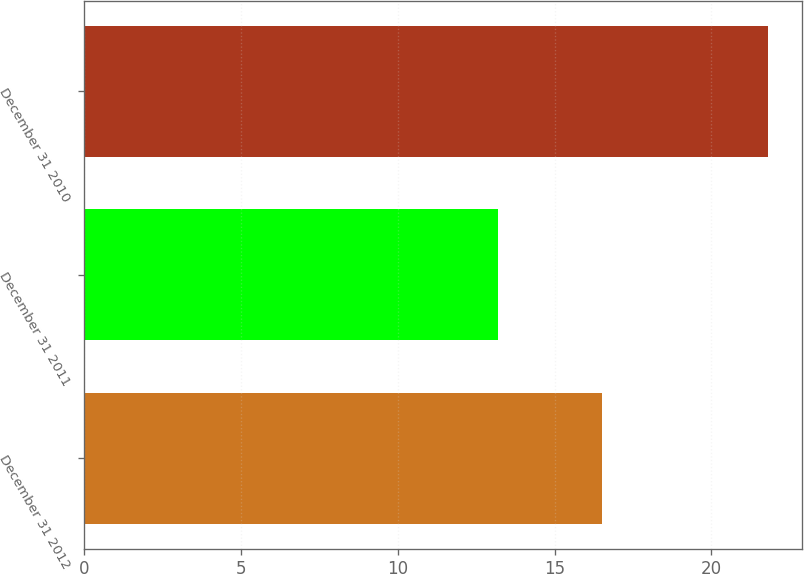Convert chart. <chart><loc_0><loc_0><loc_500><loc_500><bar_chart><fcel>December 31 2012<fcel>December 31 2011<fcel>December 31 2010<nl><fcel>16.5<fcel>13.2<fcel>21.8<nl></chart> 